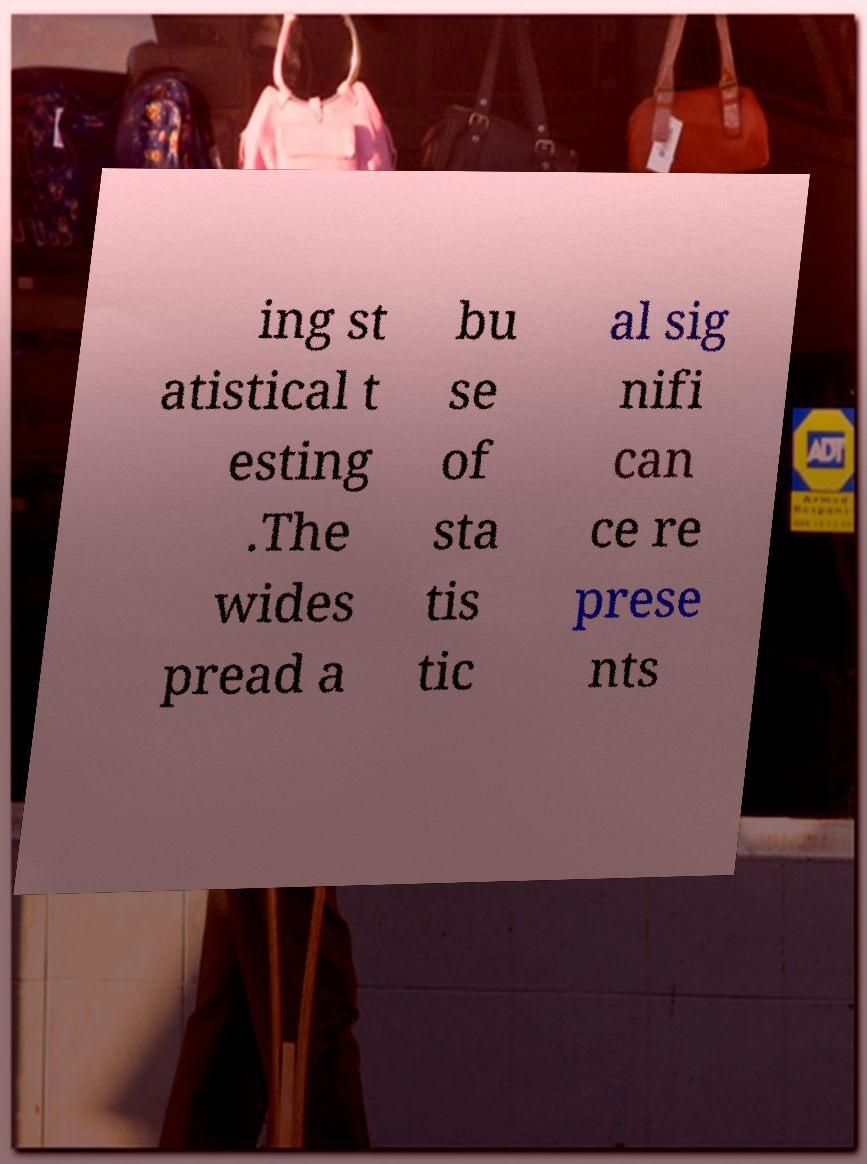Could you extract and type out the text from this image? ing st atistical t esting .The wides pread a bu se of sta tis tic al sig nifi can ce re prese nts 